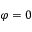<formula> <loc_0><loc_0><loc_500><loc_500>\varphi = 0</formula> 